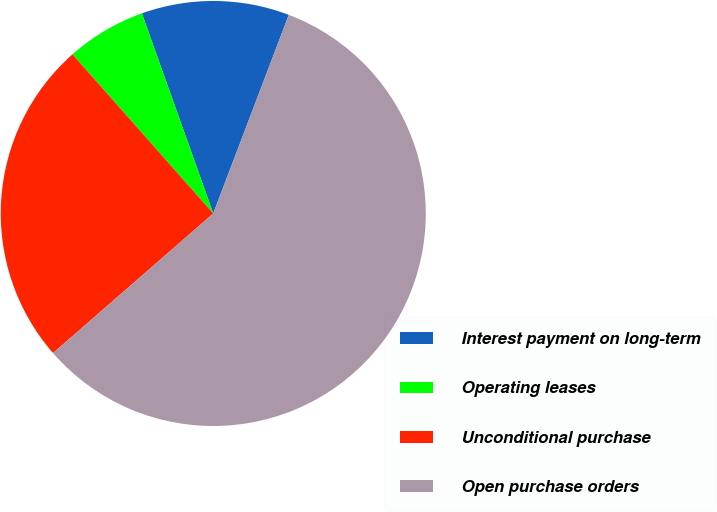<chart> <loc_0><loc_0><loc_500><loc_500><pie_chart><fcel>Interest payment on long-term<fcel>Operating leases<fcel>Unconditional purchase<fcel>Open purchase orders<nl><fcel>11.24%<fcel>6.07%<fcel>24.88%<fcel>57.81%<nl></chart> 